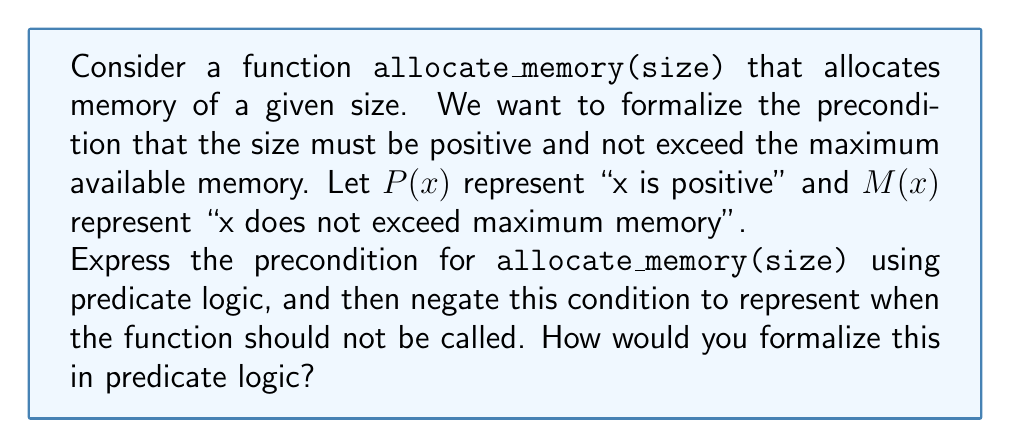What is the answer to this math problem? Let's approach this step-by-step:

1) First, we need to express the precondition for `allocate_memory(size)`:
   - The size must be positive: $P(size)$
   - The size must not exceed maximum memory: $M(size)$

2) To combine these conditions, we use the logical AND operator ($\land$):
   Precondition: $P(size) \land M(size)$

3) This means that for any size $x$, the function should only be called when:
   $\forall x (allocate\_memory(x) \rightarrow (P(x) \land M(x)))$

4) To negate this condition (i.e., when the function should not be called), we apply De Morgan's law:
   $\neg(P(size) \land M(size)) \equiv \neg P(size) \lor \neg M(size)$

5) This means the function should not be called when either:
   - The size is not positive, OR
   - The size exceeds maximum memory

6) We can express this in predicate logic as:
   $\exists x (allocate\_memory(x) \land (\neg P(x) \lor \neg M(x)))$

This formalization allows us to reason about when memory allocation should or should not occur, which is crucial for preventing memory-related errors in programming.
Answer: $\forall x (allocate\_memory(x) \rightarrow (P(x) \land M(x)))$
$\exists x (allocate\_memory(x) \land (\neg P(x) \lor \neg M(x)))$ 